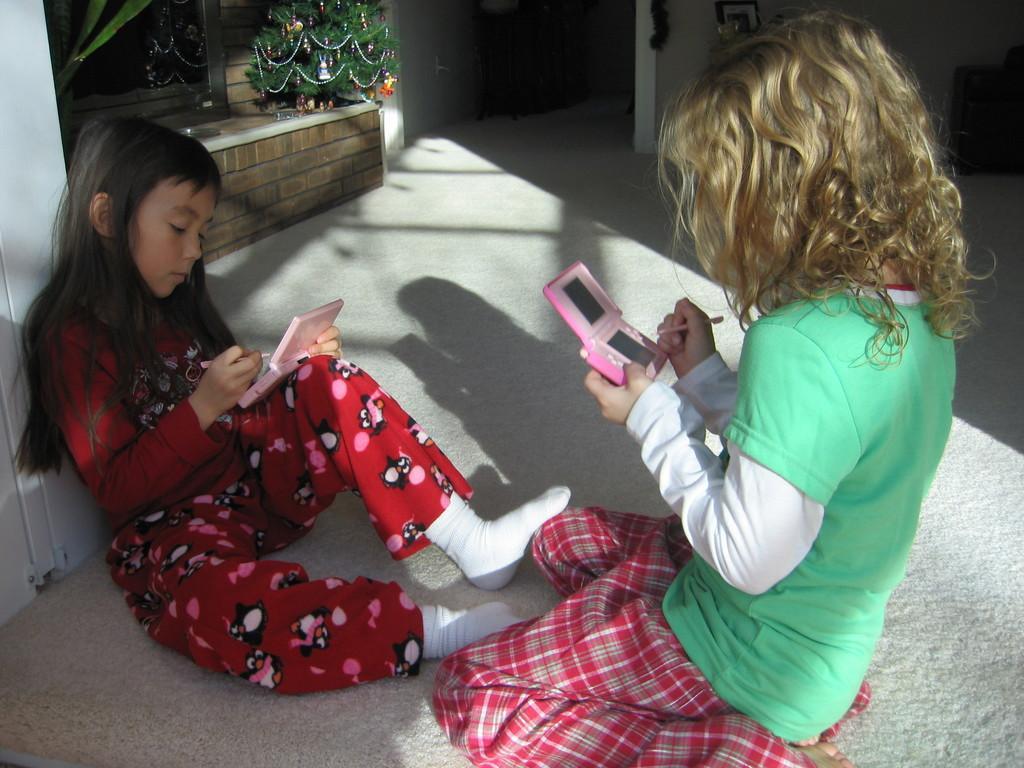How would you summarize this image in a sentence or two? This picture is inside view of a room. We can see two girls are sitting and holding an objects in their hands. At the top of the image we can mirror, christmas tree and door, wall are present. At the bottom of the image floor is there. 